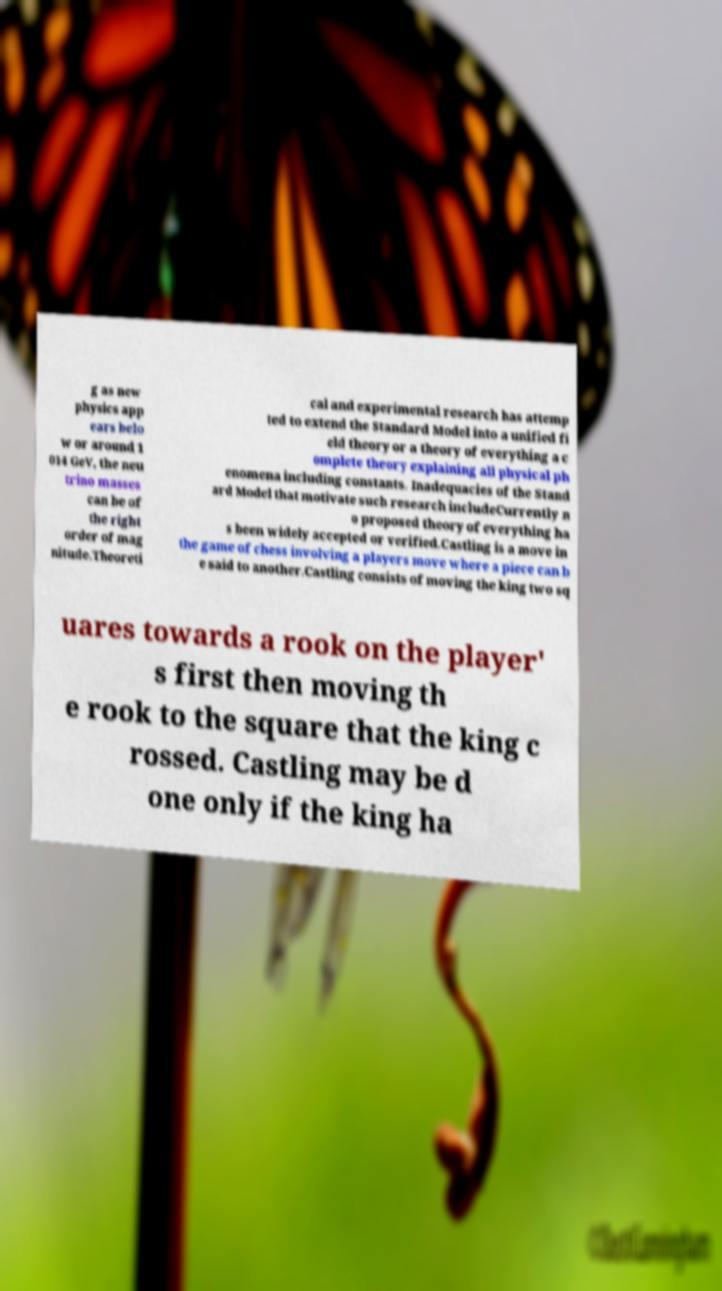Please identify and transcribe the text found in this image. g as new physics app ears belo w or around 1 014 GeV, the neu trino masses can be of the right order of mag nitude.Theoreti cal and experimental research has attemp ted to extend the Standard Model into a unified fi eld theory or a theory of everything a c omplete theory explaining all physical ph enomena including constants. Inadequacies of the Stand ard Model that motivate such research includeCurrently n o proposed theory of everything ha s been widely accepted or verified.Castling is a move in the game of chess involving a players move where a piece can b e said to another.Castling consists of moving the king two sq uares towards a rook on the player' s first then moving th e rook to the square that the king c rossed. Castling may be d one only if the king ha 